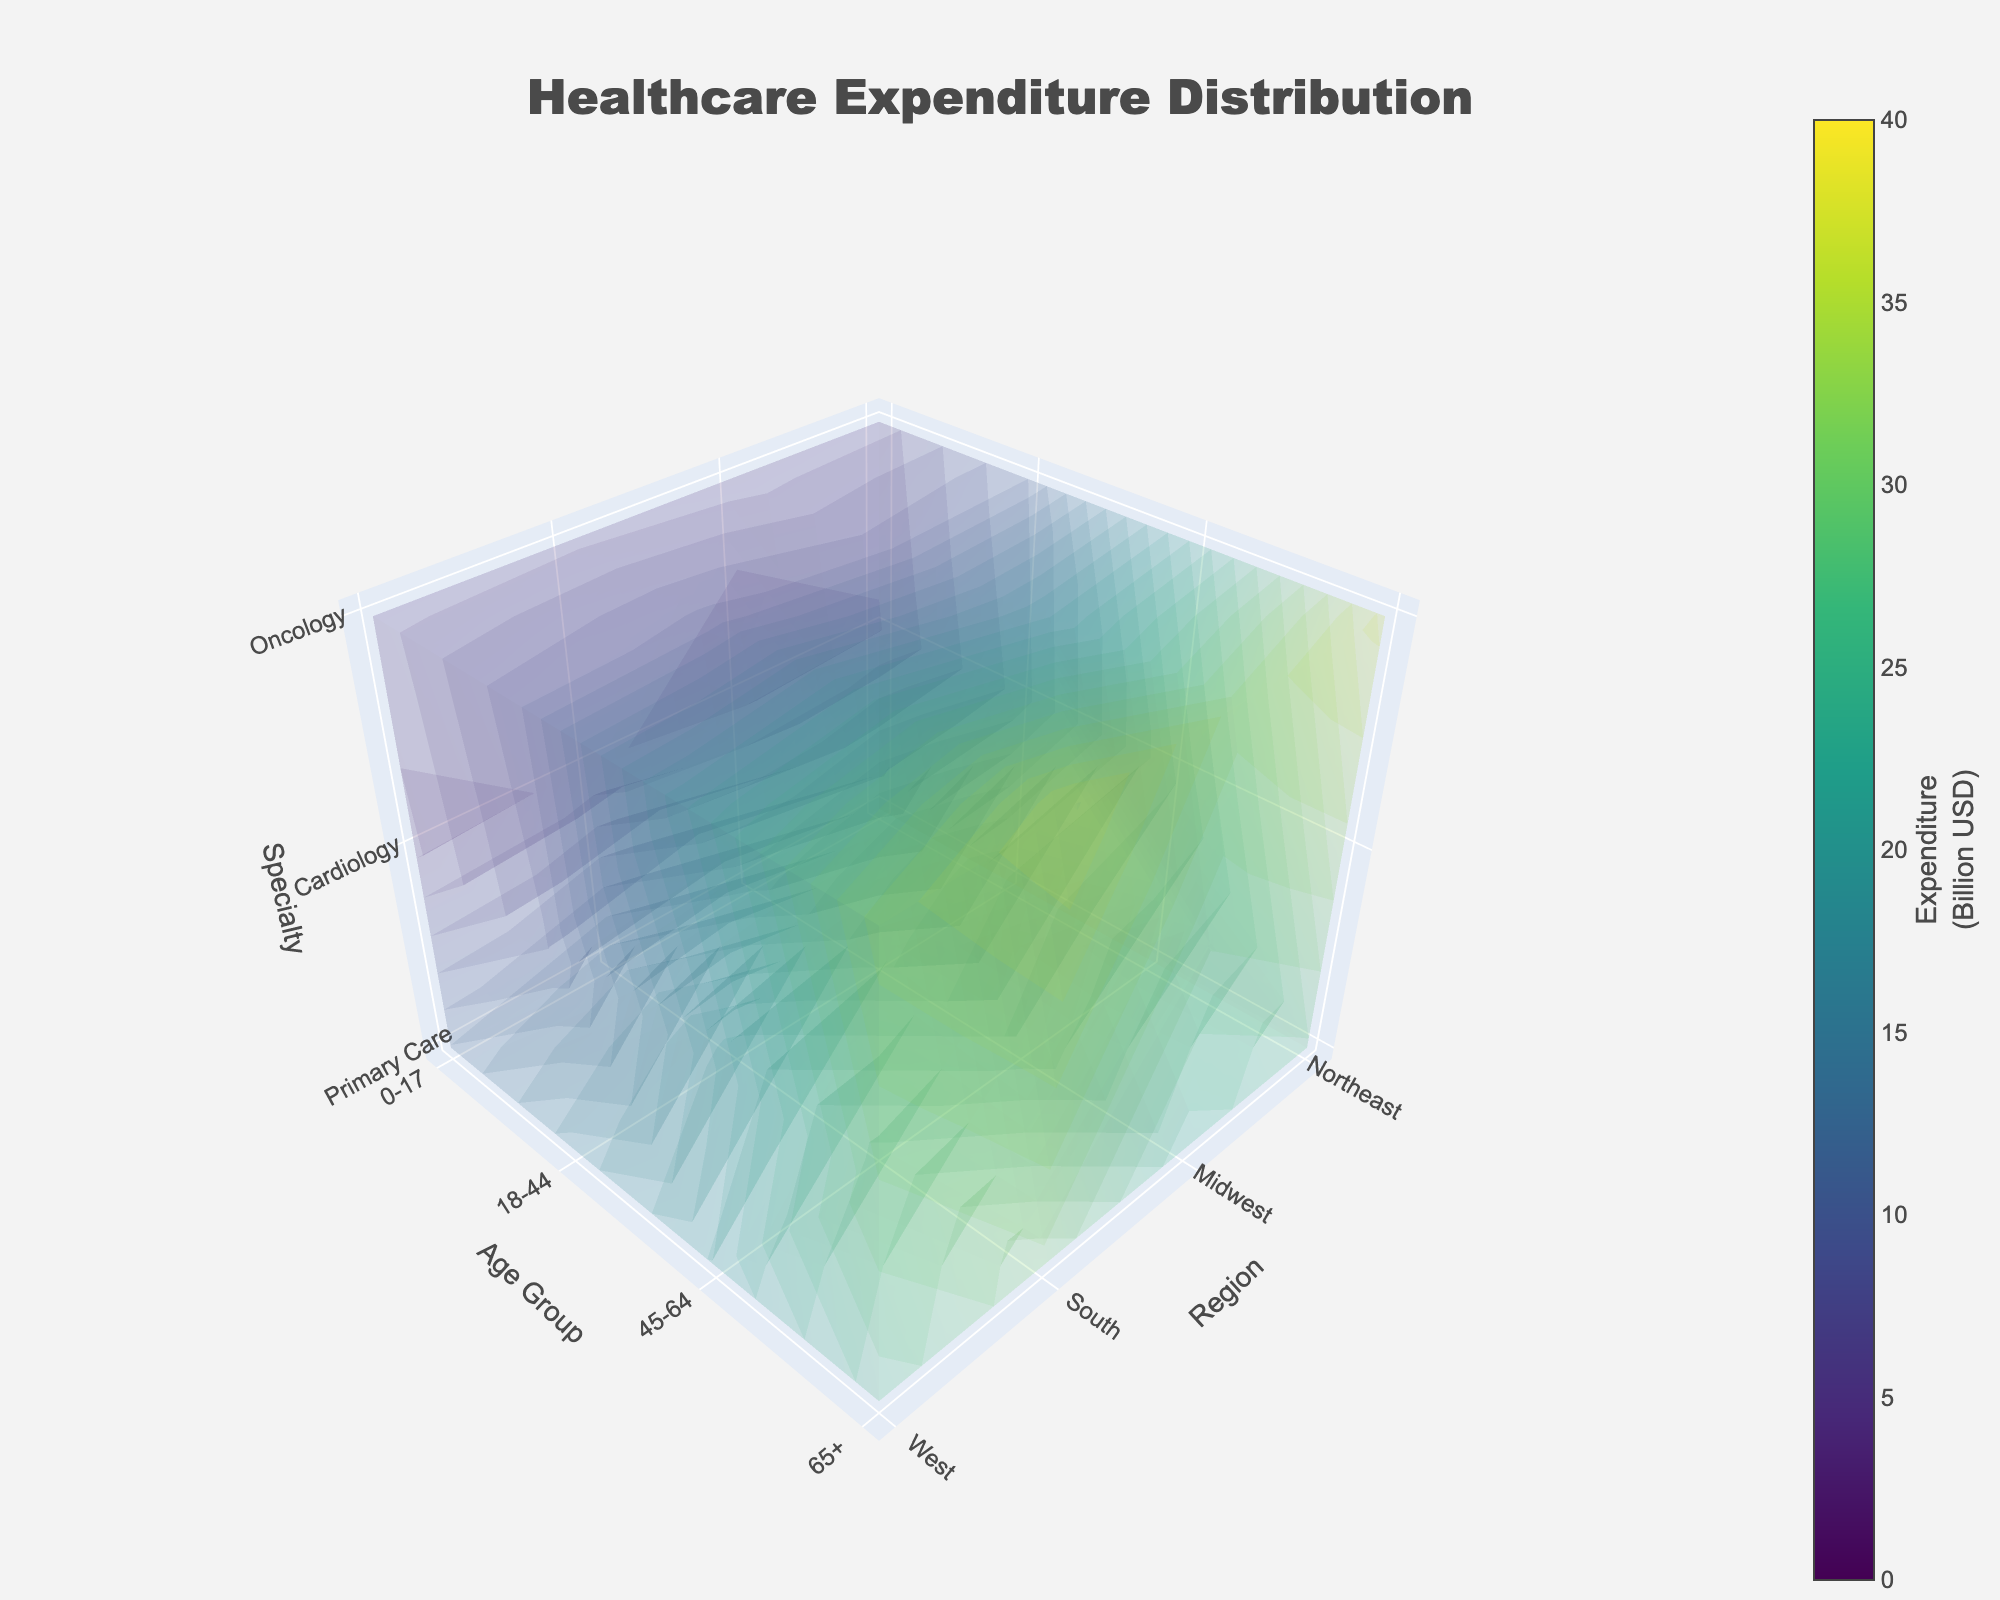What is the title of the 3D volume plot? The title can be found at the top of the plot. It typically summarizes the figure's subject.
Answer: Healthcare Expenditure Distribution Which specialty shows the highest expenditure for the 65+ age group in the South region? Locate the 'South' region on the x-axis, '65+' on the y-axis, and compare expenditures in the z-axis for each specialty.
Answer: Cardiology How does the expenditure in Primary Care for the 0-17 age group in the West compare to that of Cardiology in the same age group and region? Locate 'West' on the x-axis, '0-17' on the y-axis, then compare the values on the z-axis for Primary Care and Cardiology specialties.
Answer: Primary Care expenditure is higher What is the total healthcare expenditure for Oncology in the Midwest region across all age groups? Sum the expenditures for Oncology in the Midwest region from '0-17,' '18-44,' '45-64,' and '65+' age groups: 3.7 + 8.9 + 21.5 + 34.1 = 68.2
Answer: 68.2 Billion USD Which region has the lowest expenditure in Cardiology for the 18-44 age group? Compare the expenditure values for Cardiology across all regions for the '18-44' age group.
Answer: Midwest Are there any specialties where the expenditure consistently increases with age group across all regions? Analyze the plot to see if any specialty's expenditure appears to increase as you move from '0-17' to '65+' across all regions.
Answer: Yes, all specialties show this pattern What is the average expenditure for Primary Care in the Northeast region? Calculate the mean by summing the expenditures across all age groups for the Northeast region and dividing by the number of age groups: (12.5 + 18.3 + 22.7 + 28.1) / 4 = 20.4
Answer: 20.4 Billion USD Which specialty and age group combination in the West region shows the highest expenditure? Look at the West region along the x-axis and identify the highest expenditure value on the z-axis for all age groups and specialties.
Answer: Cardiology, 65+ 